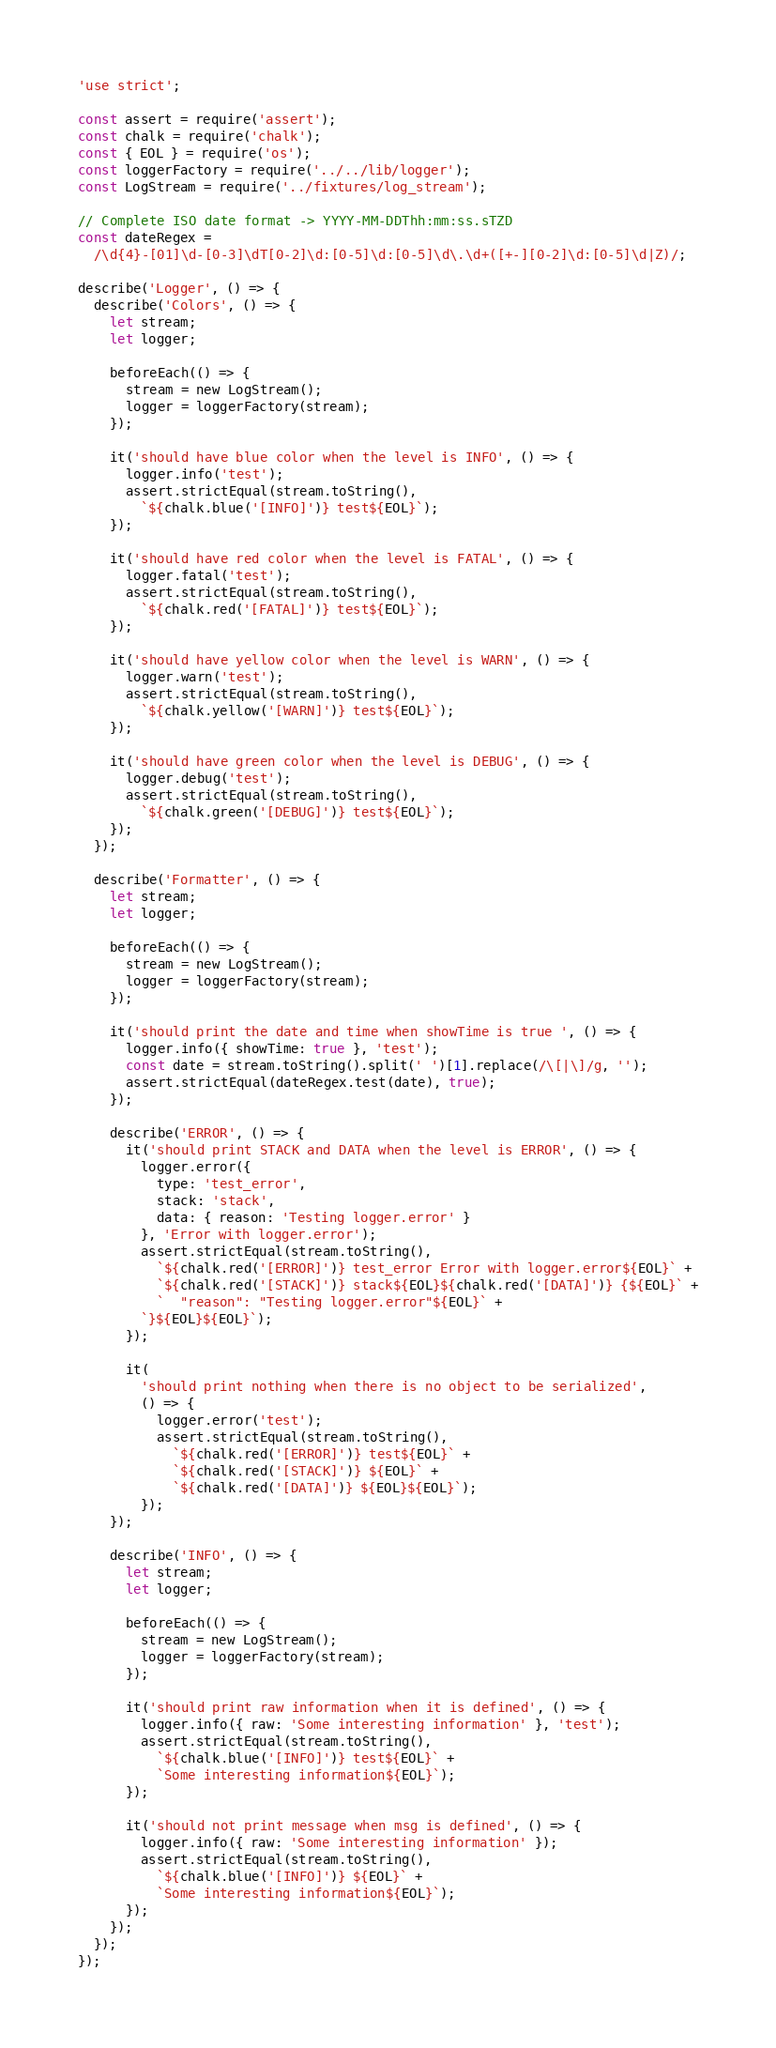<code> <loc_0><loc_0><loc_500><loc_500><_JavaScript_>'use strict';

const assert = require('assert');
const chalk = require('chalk');
const { EOL } = require('os');
const loggerFactory = require('../../lib/logger');
const LogStream = require('../fixtures/log_stream');

// Complete ISO date format -> YYYY-MM-DDThh:mm:ss.sTZD
const dateRegex =
  /\d{4}-[01]\d-[0-3]\dT[0-2]\d:[0-5]\d:[0-5]\d\.\d+([+-][0-2]\d:[0-5]\d|Z)/;

describe('Logger', () => {
  describe('Colors', () => {
    let stream;
    let logger;

    beforeEach(() => {
      stream = new LogStream();
      logger = loggerFactory(stream);
    });

    it('should have blue color when the level is INFO', () => {
      logger.info('test');
      assert.strictEqual(stream.toString(),
        `${chalk.blue('[INFO]')} test${EOL}`);
    });

    it('should have red color when the level is FATAL', () => {
      logger.fatal('test');
      assert.strictEqual(stream.toString(),
        `${chalk.red('[FATAL]')} test${EOL}`);
    });

    it('should have yellow color when the level is WARN', () => {
      logger.warn('test');
      assert.strictEqual(stream.toString(),
        `${chalk.yellow('[WARN]')} test${EOL}`);
    });

    it('should have green color when the level is DEBUG', () => {
      logger.debug('test');
      assert.strictEqual(stream.toString(),
        `${chalk.green('[DEBUG]')} test${EOL}`);
    });
  });

  describe('Formatter', () => {
    let stream;
    let logger;

    beforeEach(() => {
      stream = new LogStream();
      logger = loggerFactory(stream);
    });

    it('should print the date and time when showTime is true ', () => {
      logger.info({ showTime: true }, 'test');
      const date = stream.toString().split(' ')[1].replace(/\[|\]/g, '');
      assert.strictEqual(dateRegex.test(date), true);
    });

    describe('ERROR', () => {
      it('should print STACK and DATA when the level is ERROR', () => {
        logger.error({
          type: 'test_error',
          stack: 'stack',
          data: { reason: 'Testing logger.error' }
        }, 'Error with logger.error');
        assert.strictEqual(stream.toString(),
          `${chalk.red('[ERROR]')} test_error Error with logger.error${EOL}` +
          `${chalk.red('[STACK]')} stack${EOL}${chalk.red('[DATA]')} {${EOL}` +
          `  "reason": "Testing logger.error"${EOL}` +
        `}${EOL}${EOL}`);
      });

      it(
        'should print nothing when there is no object to be serialized',
        () => {
          logger.error('test');
          assert.strictEqual(stream.toString(),
            `${chalk.red('[ERROR]')} test${EOL}` +
            `${chalk.red('[STACK]')} ${EOL}` +
            `${chalk.red('[DATA]')} ${EOL}${EOL}`);
        });
    });

    describe('INFO', () => {
      let stream;
      let logger;

      beforeEach(() => {
        stream = new LogStream();
        logger = loggerFactory(stream);
      });

      it('should print raw information when it is defined', () => {
        logger.info({ raw: 'Some interesting information' }, 'test');
        assert.strictEqual(stream.toString(),
          `${chalk.blue('[INFO]')} test${EOL}` +
          `Some interesting information${EOL}`);
      });

      it('should not print message when msg is defined', () => {
        logger.info({ raw: 'Some interesting information' });
        assert.strictEqual(stream.toString(),
          `${chalk.blue('[INFO]')} ${EOL}` +
          `Some interesting information${EOL}`);
      });
    });
  });
});
</code> 